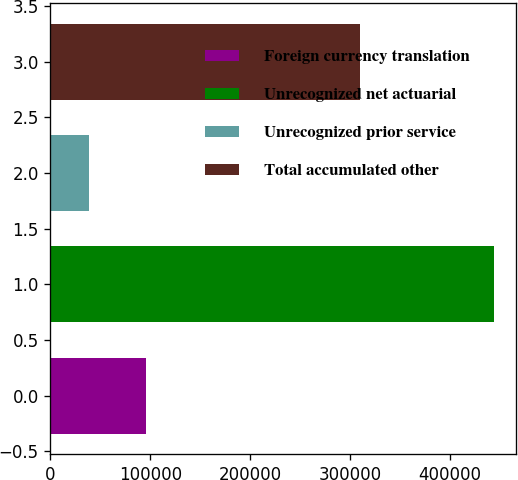Convert chart to OTSL. <chart><loc_0><loc_0><loc_500><loc_500><bar_chart><fcel>Foreign currency translation<fcel>Unrecognized net actuarial<fcel>Unrecognized prior service<fcel>Total accumulated other<nl><fcel>95513<fcel>444156<fcel>38746<fcel>309897<nl></chart> 